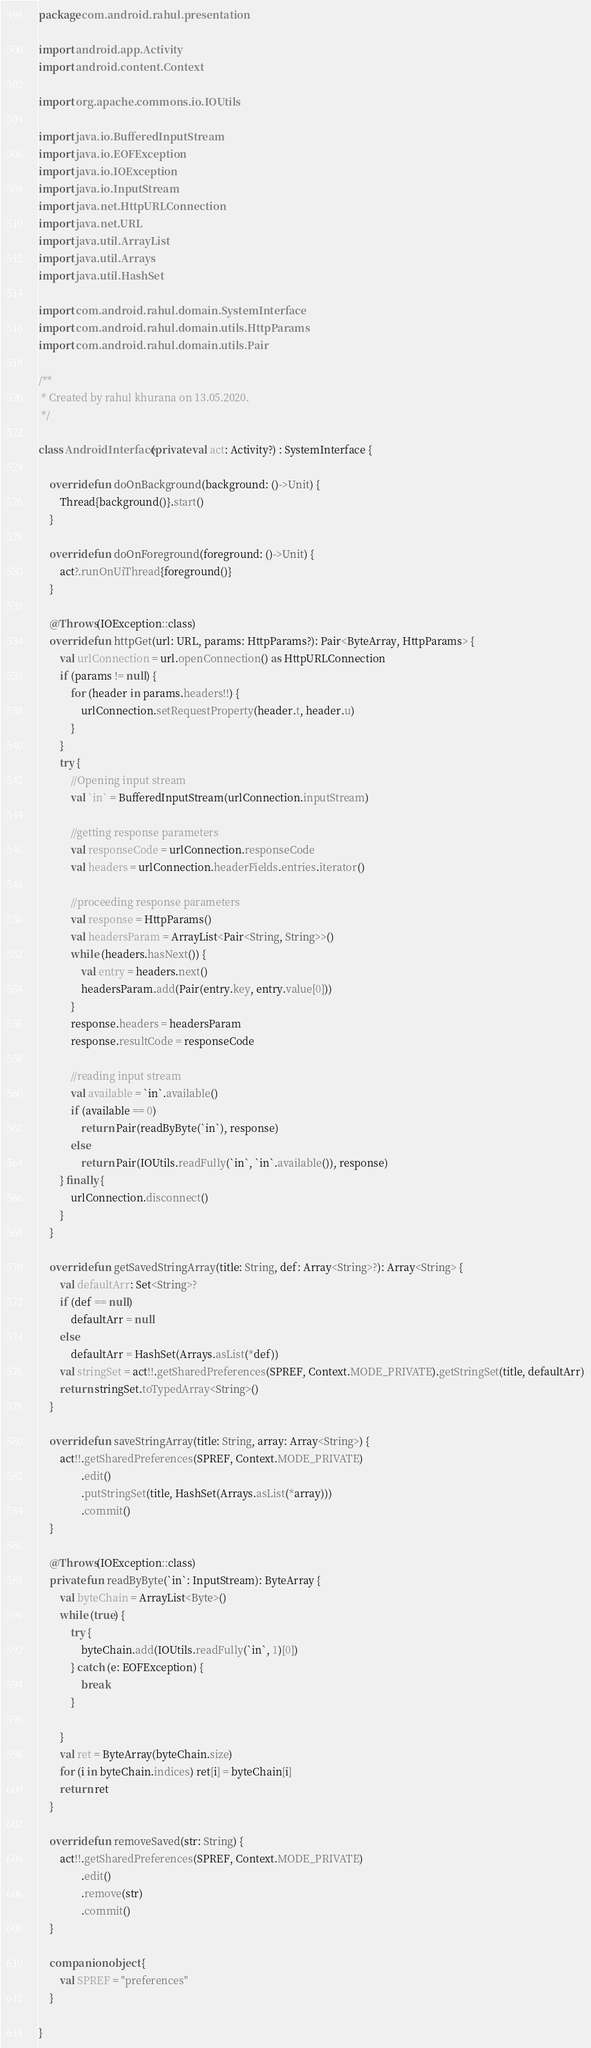Convert code to text. <code><loc_0><loc_0><loc_500><loc_500><_Kotlin_>package com.android.rahul.presentation

import android.app.Activity
import android.content.Context

import org.apache.commons.io.IOUtils

import java.io.BufferedInputStream
import java.io.EOFException
import java.io.IOException
import java.io.InputStream
import java.net.HttpURLConnection
import java.net.URL
import java.util.ArrayList
import java.util.Arrays
import java.util.HashSet

import com.android.rahul.domain.SystemInterface
import com.android.rahul.domain.utils.HttpParams
import com.android.rahul.domain.utils.Pair

/**
 * Created by rahul khurana on 13.05.2020.
 */

class AndroidInterface(private val act: Activity?) : SystemInterface {

    override fun doOnBackground(background: ()->Unit) {
        Thread{background()}.start()
    }

    override fun doOnForeground(foreground: ()->Unit) {
        act?.runOnUiThread{foreground()}
    }

    @Throws(IOException::class)
    override fun httpGet(url: URL, params: HttpParams?): Pair<ByteArray, HttpParams> {
        val urlConnection = url.openConnection() as HttpURLConnection
        if (params != null) {
            for (header in params.headers!!) {
                urlConnection.setRequestProperty(header.t, header.u)
            }
        }
        try {
            //Opening input stream
            val `in` = BufferedInputStream(urlConnection.inputStream)

            //getting response parameters
            val responseCode = urlConnection.responseCode
            val headers = urlConnection.headerFields.entries.iterator()

            //proceeding response parameters
            val response = HttpParams()
            val headersParam = ArrayList<Pair<String, String>>()
            while (headers.hasNext()) {
                val entry = headers.next()
                headersParam.add(Pair(entry.key, entry.value[0]))
            }
            response.headers = headersParam
            response.resultCode = responseCode

            //reading input stream
            val available = `in`.available()
            if (available == 0)
                return Pair(readByByte(`in`), response)
            else
                return Pair(IOUtils.readFully(`in`, `in`.available()), response)
        } finally {
            urlConnection.disconnect()
        }
    }

    override fun getSavedStringArray(title: String, def: Array<String>?): Array<String> {
        val defaultArr: Set<String>?
        if (def == null)
            defaultArr = null
        else
            defaultArr = HashSet(Arrays.asList(*def))
        val stringSet = act!!.getSharedPreferences(SPREF, Context.MODE_PRIVATE).getStringSet(title, defaultArr)
        return stringSet.toTypedArray<String>()
    }

    override fun saveStringArray(title: String, array: Array<String>) {
        act!!.getSharedPreferences(SPREF, Context.MODE_PRIVATE)
                .edit()
                .putStringSet(title, HashSet(Arrays.asList(*array)))
                .commit()
    }

    @Throws(IOException::class)
    private fun readByByte(`in`: InputStream): ByteArray {
        val byteChain = ArrayList<Byte>()
        while (true) {
            try {
                byteChain.add(IOUtils.readFully(`in`, 1)[0])
            } catch (e: EOFException) {
                break
            }

        }
        val ret = ByteArray(byteChain.size)
        for (i in byteChain.indices) ret[i] = byteChain[i]
        return ret
    }

    override fun removeSaved(str: String) {
        act!!.getSharedPreferences(SPREF, Context.MODE_PRIVATE)
                .edit()
                .remove(str)
                .commit()
    }

    companion object {
        val SPREF = "preferences"
    }

}
</code> 